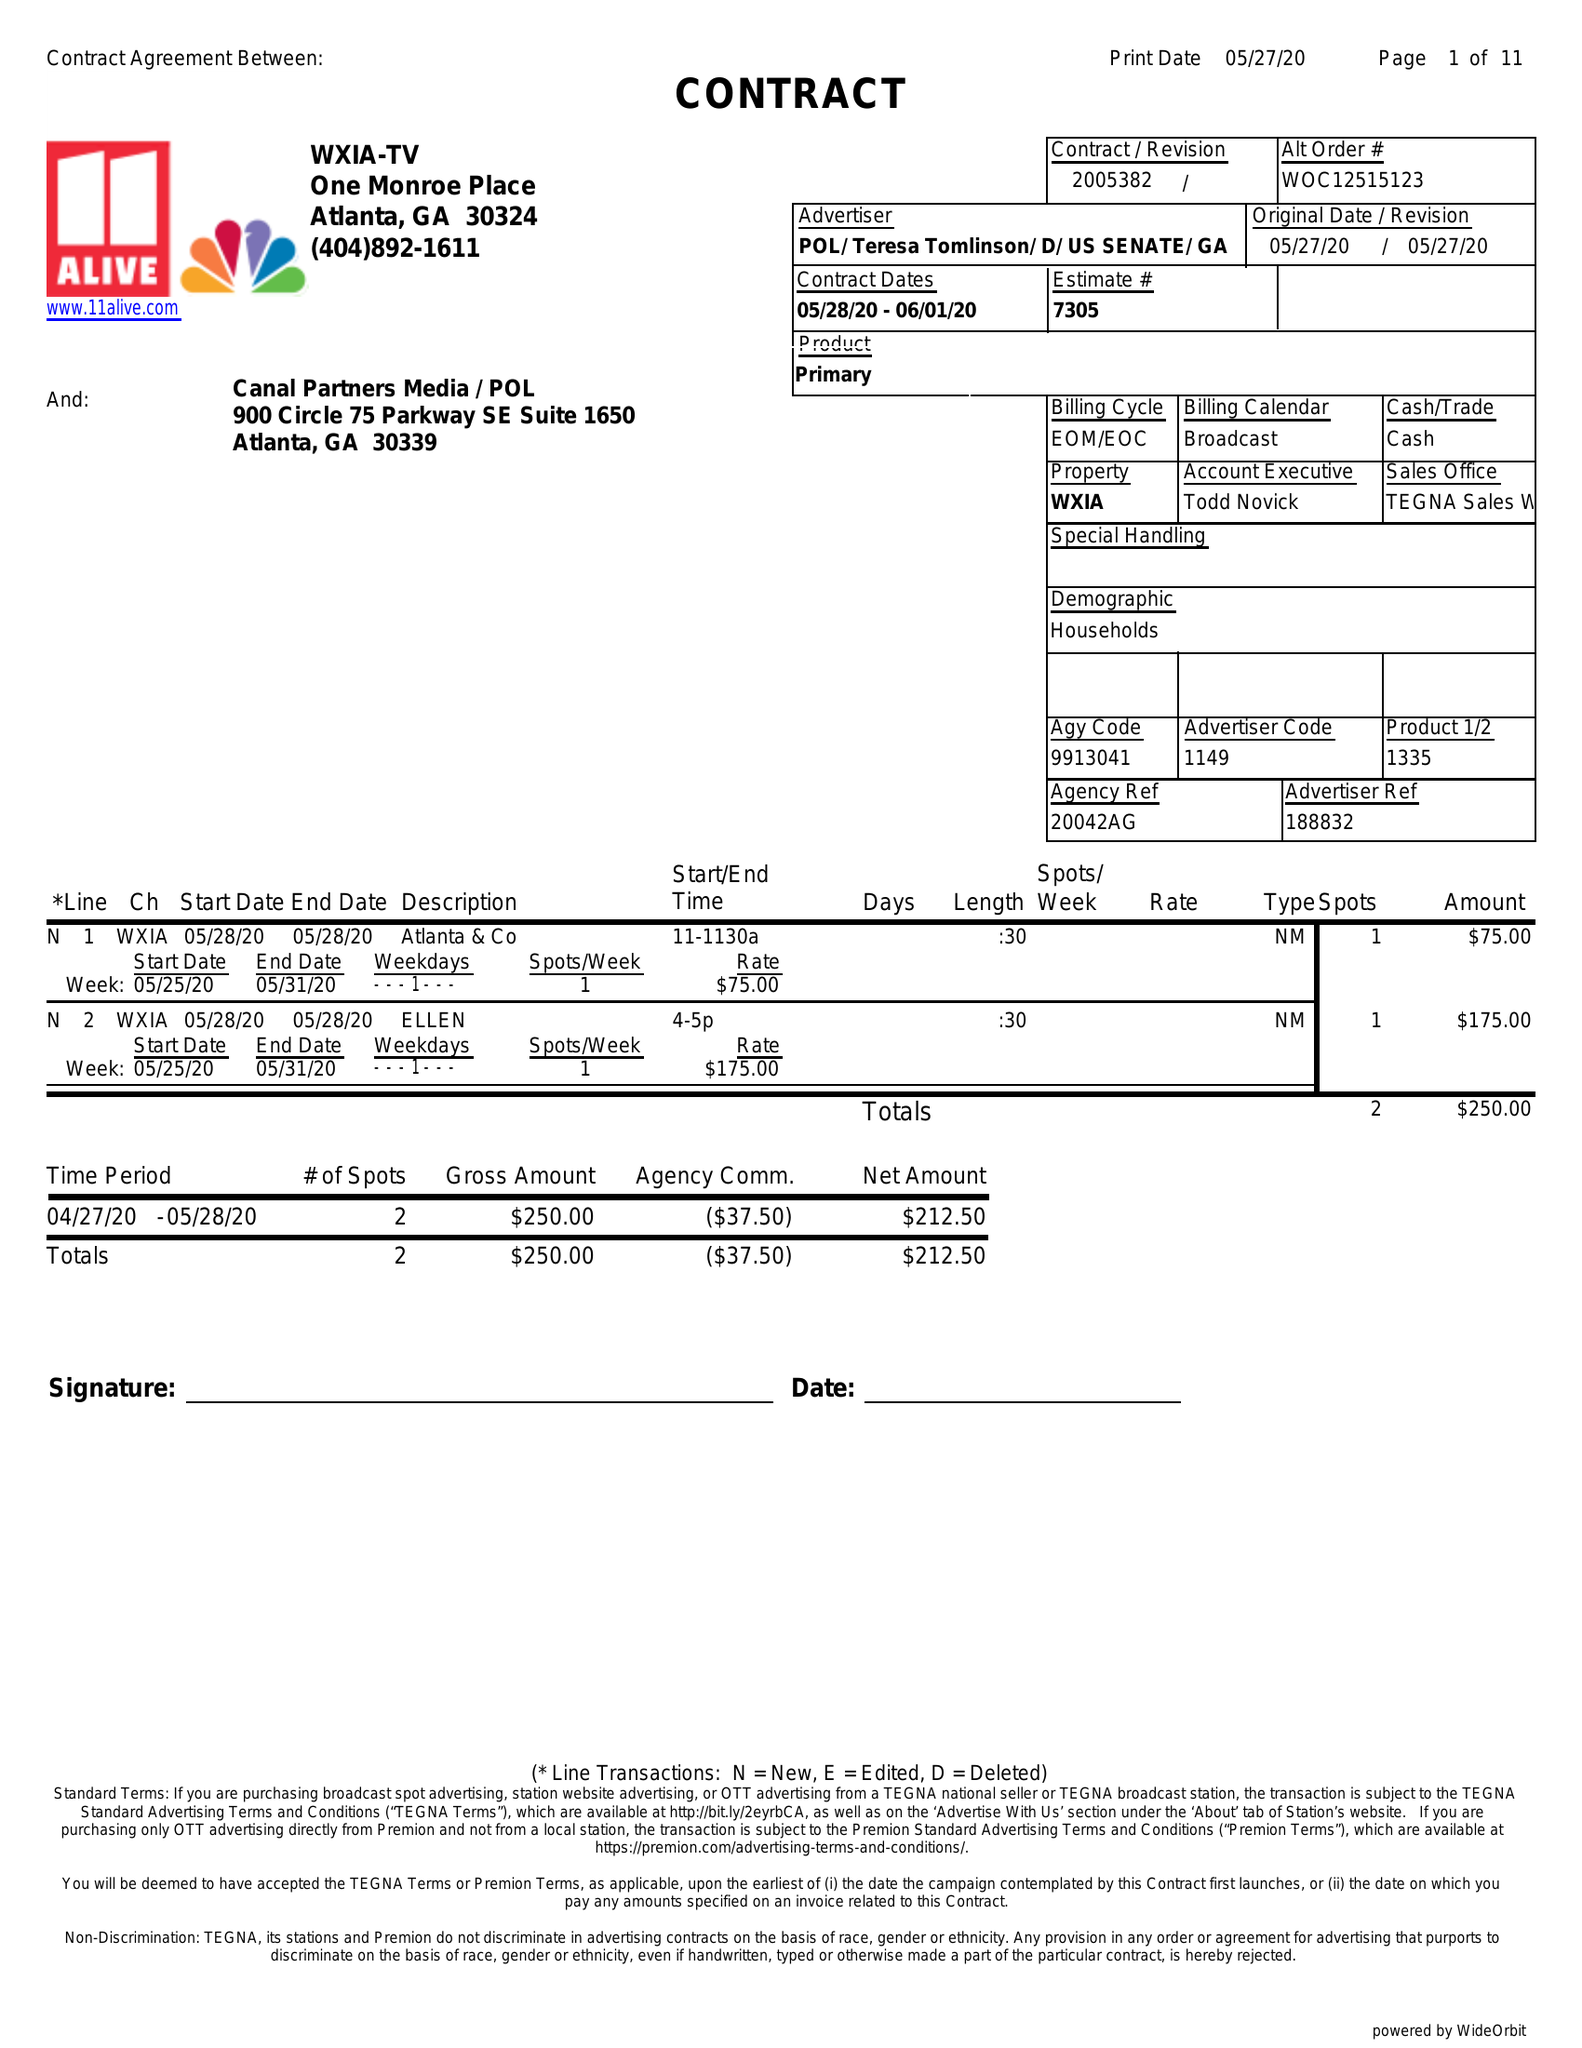What is the value for the advertiser?
Answer the question using a single word or phrase. POL/TERESATOMLINSON/D/USSENATE/GA 